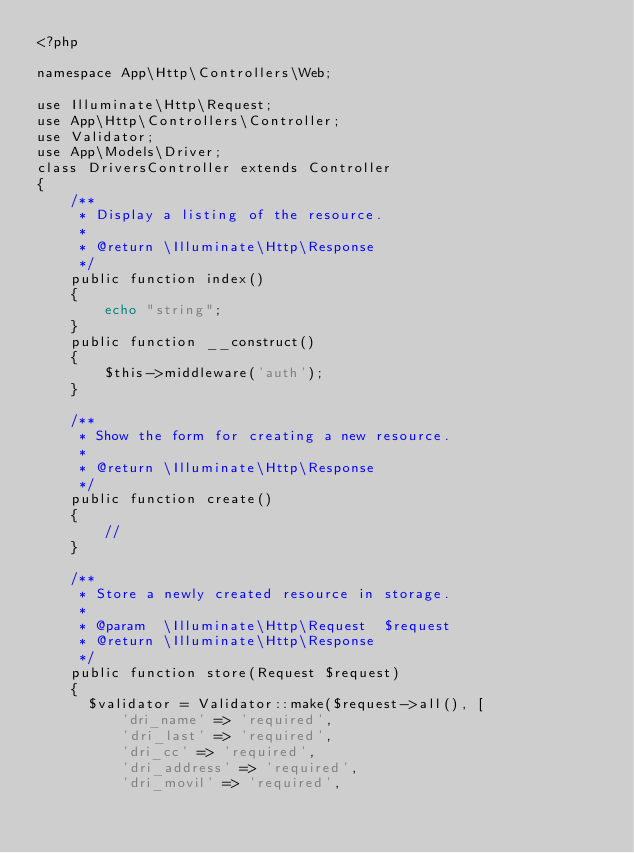Convert code to text. <code><loc_0><loc_0><loc_500><loc_500><_PHP_><?php

namespace App\Http\Controllers\Web;

use Illuminate\Http\Request;
use App\Http\Controllers\Controller;
use Validator;
use App\Models\Driver;
class DriversController extends Controller
{
    /**
     * Display a listing of the resource.
     *
     * @return \Illuminate\Http\Response
     */
    public function index()
    {
        echo "string";
    }
    public function __construct()
    {
        $this->middleware('auth');
    }

    /**
     * Show the form for creating a new resource.
     *
     * @return \Illuminate\Http\Response
     */
    public function create()
    {
        //
    }

    /**
     * Store a newly created resource in storage.
     *
     * @param  \Illuminate\Http\Request  $request
     * @return \Illuminate\Http\Response
     */
    public function store(Request $request)
    {
      $validator = Validator::make($request->all(), [
          'dri_name' => 'required',
          'dri_last' => 'required',
          'dri_cc' => 'required',
          'dri_address' => 'required',
          'dri_movil' => 'required',</code> 